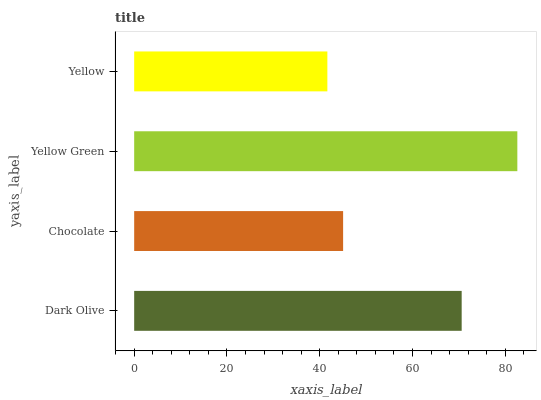Is Yellow the minimum?
Answer yes or no. Yes. Is Yellow Green the maximum?
Answer yes or no. Yes. Is Chocolate the minimum?
Answer yes or no. No. Is Chocolate the maximum?
Answer yes or no. No. Is Dark Olive greater than Chocolate?
Answer yes or no. Yes. Is Chocolate less than Dark Olive?
Answer yes or no. Yes. Is Chocolate greater than Dark Olive?
Answer yes or no. No. Is Dark Olive less than Chocolate?
Answer yes or no. No. Is Dark Olive the high median?
Answer yes or no. Yes. Is Chocolate the low median?
Answer yes or no. Yes. Is Yellow Green the high median?
Answer yes or no. No. Is Dark Olive the low median?
Answer yes or no. No. 